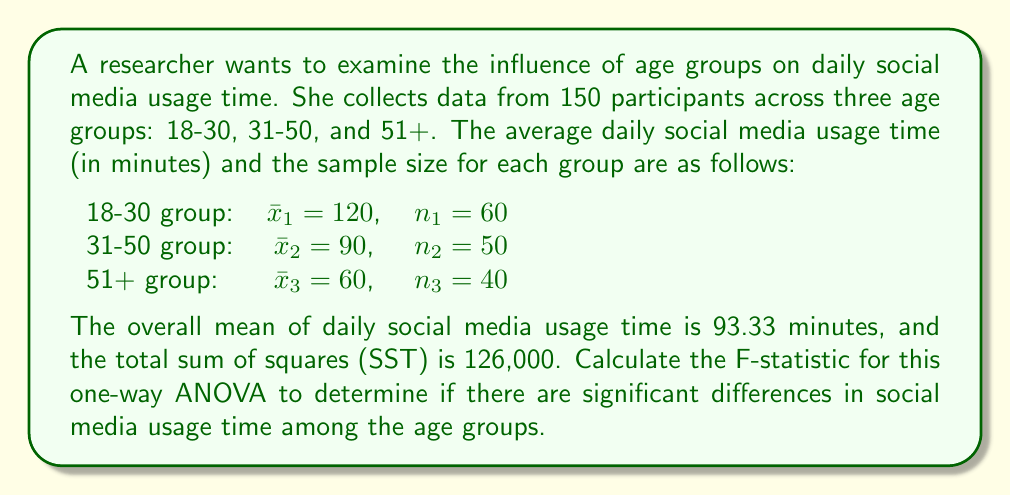Teach me how to tackle this problem. To calculate the F-statistic for a one-way ANOVA, we need to follow these steps:

1. Calculate the between-group sum of squares (SSB)
2. Calculate the within-group sum of squares (SSW)
3. Calculate the degrees of freedom (df) for between-group and within-group
4. Calculate the mean square between (MSB) and mean square within (MSW)
5. Calculate the F-statistic

Step 1: Calculate SSB
SSB = $\sum_{i=1}^k n_i(\bar{x}_i - \bar{x})^2$, where $k$ is the number of groups, $n_i$ is the sample size of each group, $\bar{x}_i$ is the mean of each group, and $\bar{x}$ is the overall mean.

SSB = $60(120 - 93.33)^2 + 50(90 - 93.33)^2 + 40(60 - 93.33)^2$
SSB = $60(26.67)^2 + 50(-3.33)^2 + 40(-33.33)^2$
SSB = $42,680 + 555 + 44,440 = 87,675$

Step 2: Calculate SSW
SSW = SST - SSB = $126,000 - 87,675 = 38,325$

Step 3: Calculate degrees of freedom (df)
df between = $k - 1 = 3 - 1 = 2$
df within = $N - k = 150 - 3 = 147$, where $N$ is the total sample size

Step 4: Calculate MSB and MSW
MSB = SSB / df between = $87,675 / 2 = 43,837.5$
MSW = SSW / df within = $38,325 / 147 = 260.71$

Step 5: Calculate the F-statistic
F = MSB / MSW = $43,837.5 / 260.71 = 168.15$
Answer: The F-statistic for this one-way ANOVA is 168.15. 